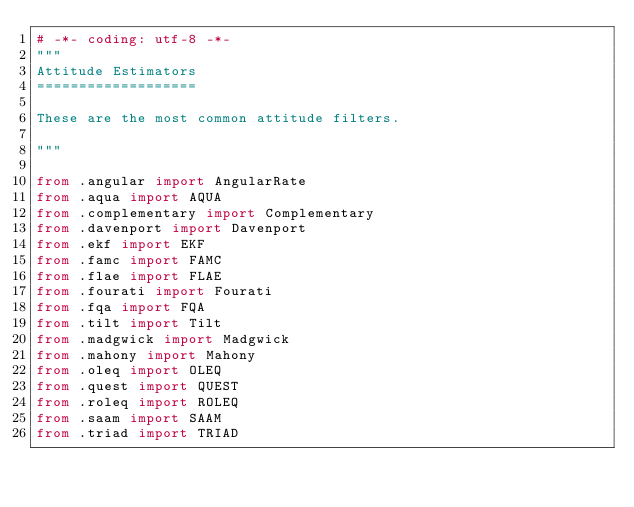Convert code to text. <code><loc_0><loc_0><loc_500><loc_500><_Python_># -*- coding: utf-8 -*-
"""
Attitude Estimators
===================

These are the most common attitude filters.

"""

from .angular import AngularRate
from .aqua import AQUA
from .complementary import Complementary
from .davenport import Davenport
from .ekf import EKF
from .famc import FAMC
from .flae import FLAE
from .fourati import Fourati
from .fqa import FQA
from .tilt import Tilt
from .madgwick import Madgwick
from .mahony import Mahony
from .oleq import OLEQ
from .quest import QUEST
from .roleq import ROLEQ
from .saam import SAAM
from .triad import TRIAD
</code> 